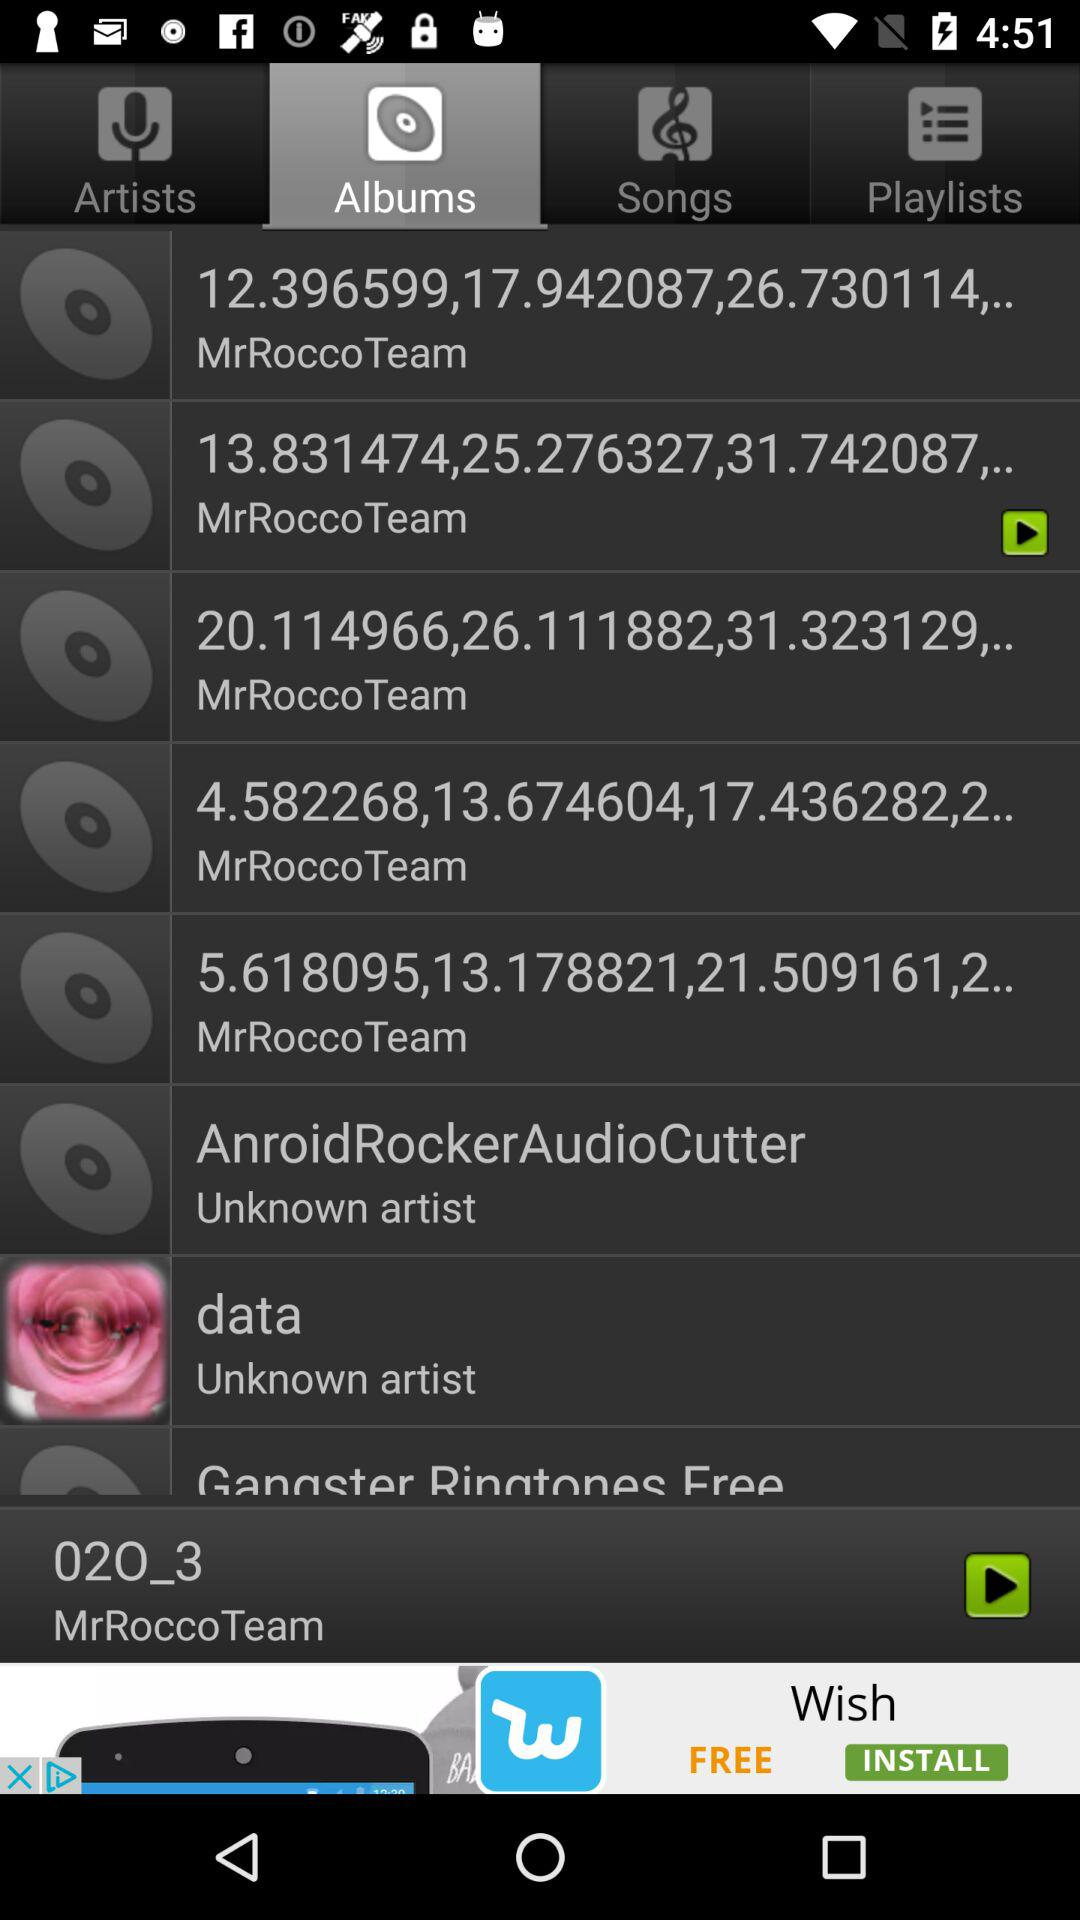How long is "02O_3"?
When the provided information is insufficient, respond with <no answer>. <no answer> 